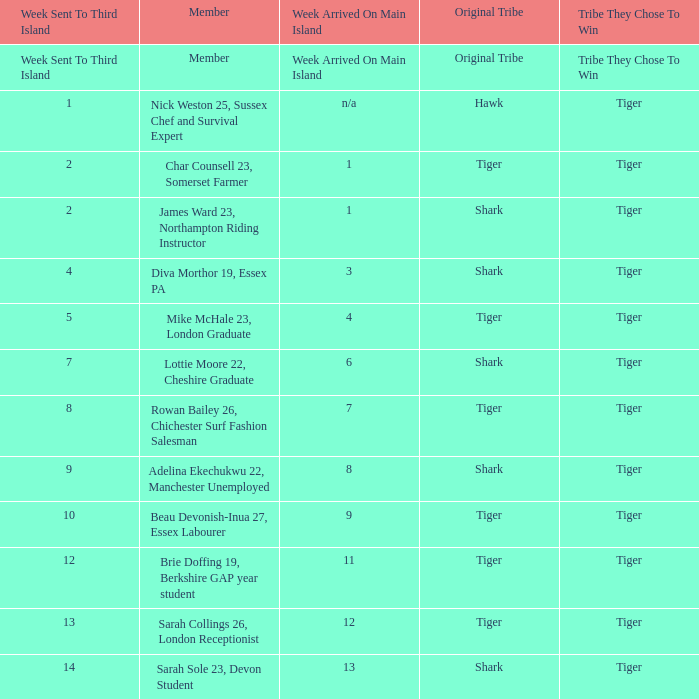What week was the member who arrived on the main island in week 6 sent to the third island? 7.0. 